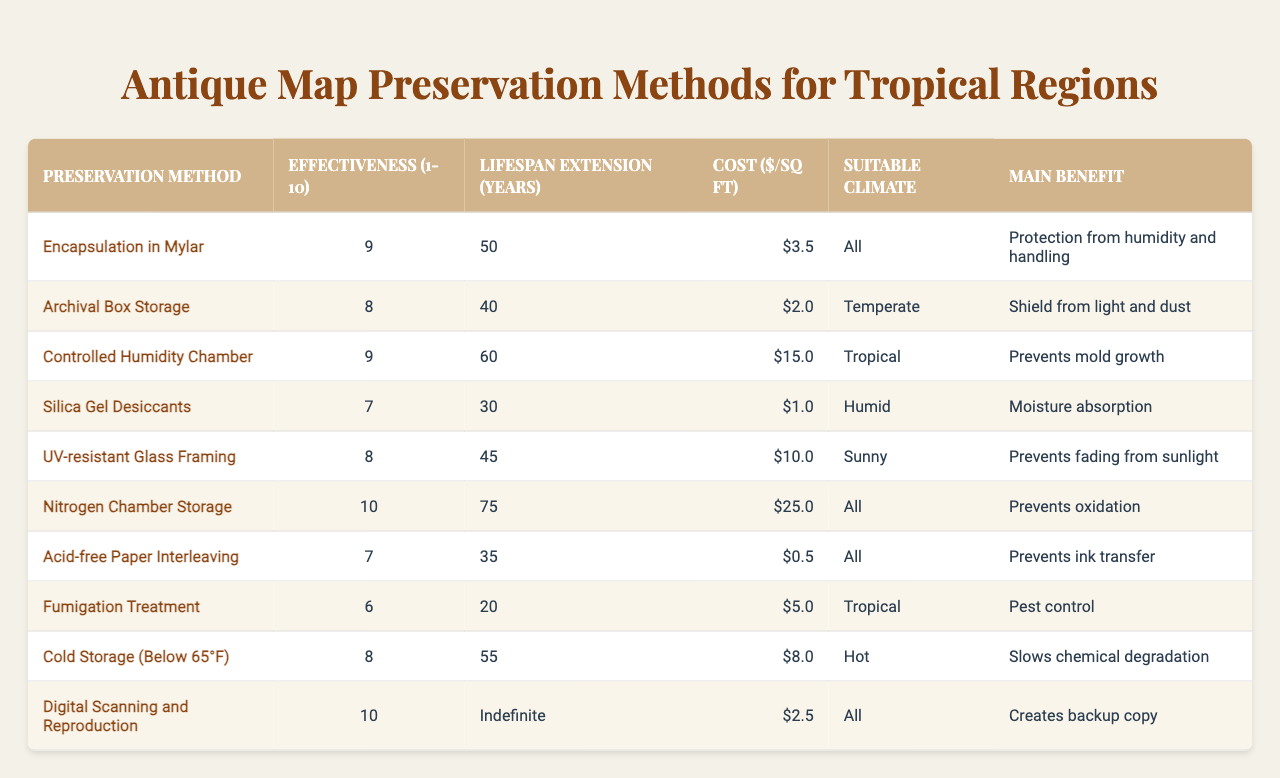What is the effectiveness rating of Nitrogen Chamber Storage? The effectiveness rating of Nitrogen Chamber Storage is listed as 10 in the table.
Answer: 10 Which preservation method offers the longest lifespan extension? Looking through the Lifespan Extension column, Controlled Humidity Chamber extends lifespan by 60 years, while Nitrogen Chamber Storage offers 75 years, making it the longest.
Answer: 75 years Does the Cold Storage method suit tropical climates? The Suitable Climate for Cold Storage is listed as "Hot," which indicates it does not suit tropical climates.
Answer: No What is the cost per square foot for the Controlled Humidity Chamber? The table shows that the cost for Controlled Humidity Chamber is $15.00 per square foot.
Answer: $15.00 What preservation methods can protect against humidity? Encapsulation in Mylar, Controlled Humidity Chamber, and Silica Gel Desiccants are aimed at protecting against humidity, as noted in their main benefits.
Answer: 3 methods Find the average effectiveness rating of all preservation methods listed. To find the average, we sum all effectiveness ratings (9 + 8 + 9 + 7 + 8 + 10 + 7 + 6 + 8 + 10 = 80). There are 10 methods, so the average is 80/10 = 8.
Answer: 8 Which method has the lowest cost per square foot, and what is that cost? The table shows Acid-free Paper Interleaving has the lowest cost at $0.50 per square foot.
Answer: $0.50 Are there any preservation methods that prevent oxidation? Nitrogen Chamber Storage is the only method that specifically indicates it prevents oxidation in the main benefit section.
Answer: Yes What is the total lifespan extension from Fumigation Treatment and Acid-free Paper Interleaving combined? Fumigation Treatment extends lifespan by 20 years and Acid-free Paper Interleaving by 35 years. Combined, they total 20 + 35 = 55 years.
Answer: 55 years Which preservation method has the highest effectiveness and what is its main benefit? Nitrogen Chamber Storage has the highest effectiveness rating of 10, and its main benefit is that it prevents oxidation.
Answer: Prevents oxidation 